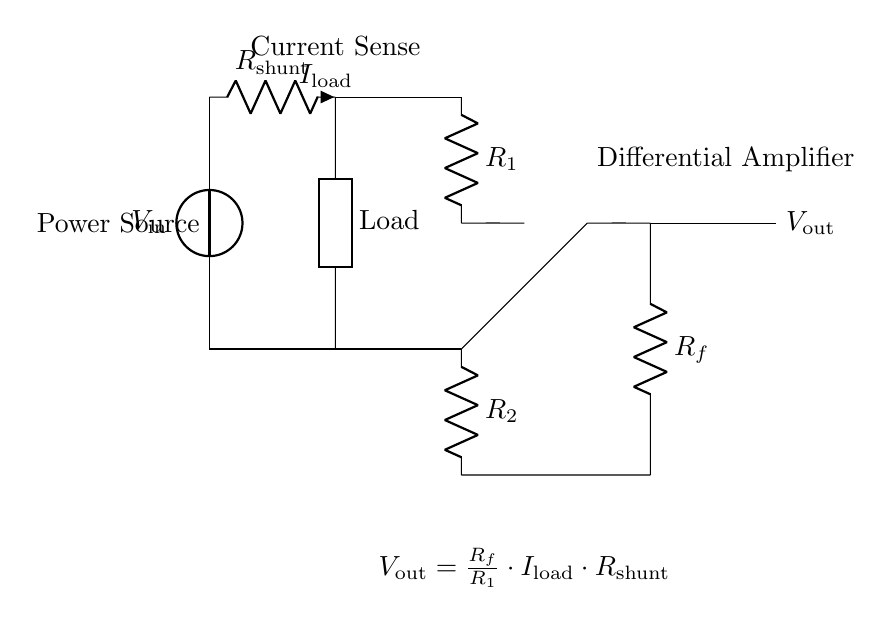What is the input voltage in the circuit? The input voltage is labeled as V_in, which is the voltage supplied to the circuit and can be observed at the top left corner of the diagram.
Answer: V_in What is the value of the shunt resistor? The shunt resistor is denoted as R_shunt in the circuit diagram, located in series with the load and responsible for the current sensing.
Answer: R_shunt What does V_out represent? V_out is the output voltage of the differential amplifier circuit, which is shown at the rightmost part of the diagram and indicates the amplified signal corresponding to the load current.
Answer: V_out How is the output voltage calculated? The output voltage V_out is calculated using the formula V_out = (R_f / R_1) * I_load * R_shunt, which shows the relationship between the output voltage, the resistor values, and the load current in the circuit. This can be observed in the equation labeled below the circuit.
Answer: (R_f / R_1) * I_load * R_shunt What is the purpose of the differential amplifier in this circuit? The differential amplifier amplifies the voltage difference across the shunt resistor, allowing for precise measurement of the current flowing through the circuit. Its function is crucial for monitoring the power consumption accurately.
Answer: To amplify the current sense voltage What is the role of the load in this circuit? The load represents the device whose power consumption is being monitored, and it connects to the output of the shunt resistor, facilitating the sensing of the load current.
Answer: To represent the device consuming power 